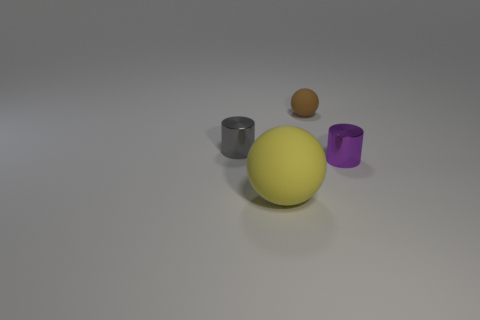Add 2 large green rubber balls. How many objects exist? 6 Add 4 rubber objects. How many rubber objects exist? 6 Subtract 0 red cylinders. How many objects are left? 4 Subtract all metallic things. Subtract all large objects. How many objects are left? 1 Add 2 spheres. How many spheres are left? 4 